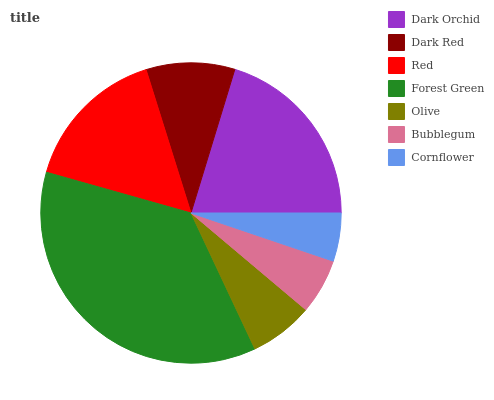Is Cornflower the minimum?
Answer yes or no. Yes. Is Forest Green the maximum?
Answer yes or no. Yes. Is Dark Red the minimum?
Answer yes or no. No. Is Dark Red the maximum?
Answer yes or no. No. Is Dark Orchid greater than Dark Red?
Answer yes or no. Yes. Is Dark Red less than Dark Orchid?
Answer yes or no. Yes. Is Dark Red greater than Dark Orchid?
Answer yes or no. No. Is Dark Orchid less than Dark Red?
Answer yes or no. No. Is Dark Red the high median?
Answer yes or no. Yes. Is Dark Red the low median?
Answer yes or no. Yes. Is Cornflower the high median?
Answer yes or no. No. Is Olive the low median?
Answer yes or no. No. 